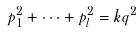Convert formula to latex. <formula><loc_0><loc_0><loc_500><loc_500>p _ { 1 } ^ { 2 } + \cdots + p _ { l } ^ { 2 } = k q ^ { 2 }</formula> 